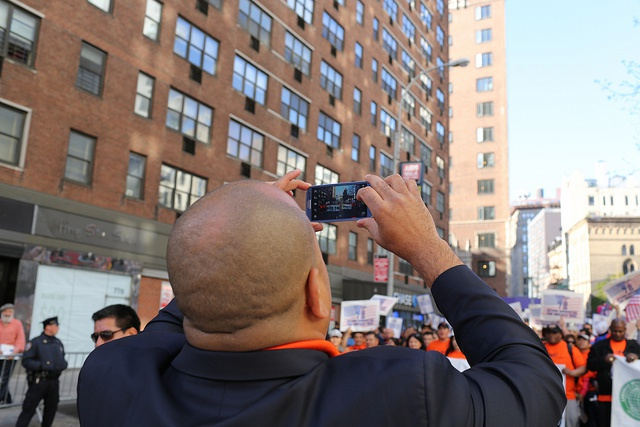Describe the objects in this image and their specific colors. I can see people in gray, black, and brown tones, people in gray, darkgray, black, and lightgray tones, people in gray, black, and darkgray tones, people in gray, black, maroon, and red tones, and people in gray, red, black, and maroon tones in this image. 